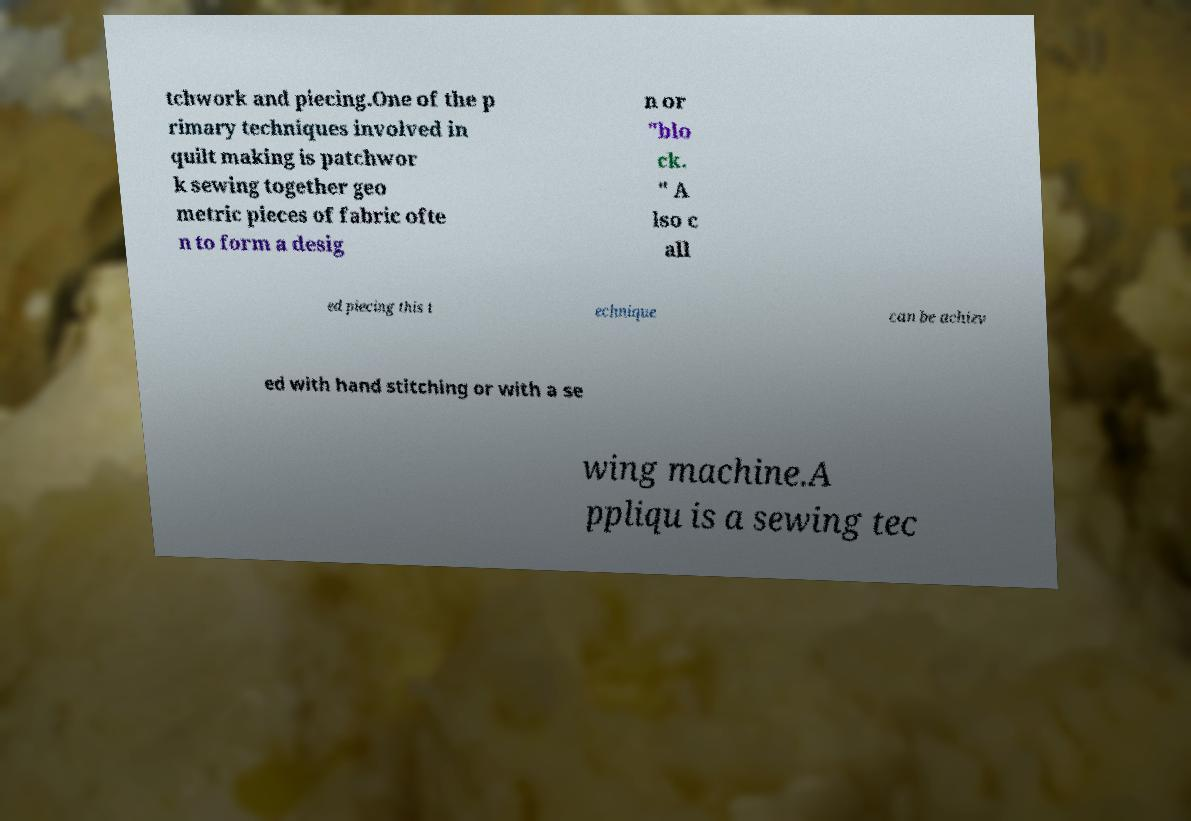Can you read and provide the text displayed in the image?This photo seems to have some interesting text. Can you extract and type it out for me? tchwork and piecing.One of the p rimary techniques involved in quilt making is patchwor k sewing together geo metric pieces of fabric ofte n to form a desig n or "blo ck. " A lso c all ed piecing this t echnique can be achiev ed with hand stitching or with a se wing machine.A ppliqu is a sewing tec 